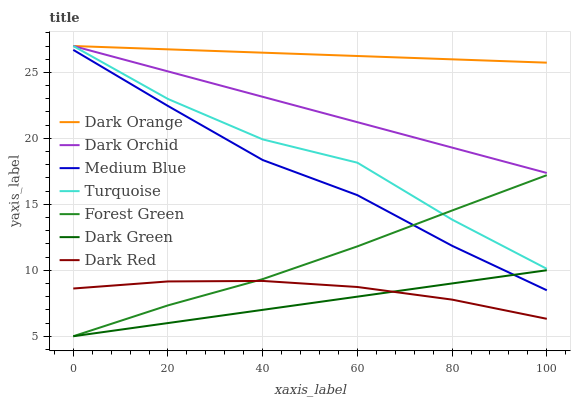Does Dark Green have the minimum area under the curve?
Answer yes or no. Yes. Does Dark Orange have the maximum area under the curve?
Answer yes or no. Yes. Does Turquoise have the minimum area under the curve?
Answer yes or no. No. Does Turquoise have the maximum area under the curve?
Answer yes or no. No. Is Dark Orange the smoothest?
Answer yes or no. Yes. Is Turquoise the roughest?
Answer yes or no. Yes. Is Dark Red the smoothest?
Answer yes or no. No. Is Dark Red the roughest?
Answer yes or no. No. Does Forest Green have the lowest value?
Answer yes or no. Yes. Does Turquoise have the lowest value?
Answer yes or no. No. Does Dark Orchid have the highest value?
Answer yes or no. Yes. Does Dark Red have the highest value?
Answer yes or no. No. Is Dark Red less than Turquoise?
Answer yes or no. Yes. Is Dark Orchid greater than Forest Green?
Answer yes or no. Yes. Does Forest Green intersect Dark Red?
Answer yes or no. Yes. Is Forest Green less than Dark Red?
Answer yes or no. No. Is Forest Green greater than Dark Red?
Answer yes or no. No. Does Dark Red intersect Turquoise?
Answer yes or no. No. 